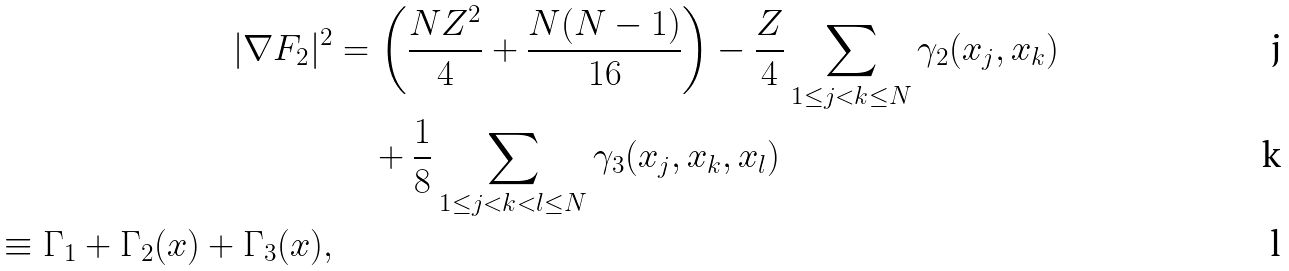Convert formula to latex. <formula><loc_0><loc_0><loc_500><loc_500>| \nabla F _ { 2 } | ^ { 2 } & = \left ( \frac { N Z ^ { 2 } } { 4 } + \frac { N ( N - 1 ) } { 1 6 } \right ) - \frac { Z } { 4 } \sum _ { 1 \leq j < k \leq N } \gamma _ { 2 } ( x _ { j } , x _ { k } ) \\ & \quad + \frac { 1 } { 8 } \sum _ { 1 \leq j < k < l \leq N } \gamma _ { 3 } ( x _ { j } , x _ { k } , x _ { l } ) \\ \equiv \Gamma _ { 1 } + \Gamma _ { 2 } ( { x } ) + \Gamma _ { 3 } ( { x } ) ,</formula> 